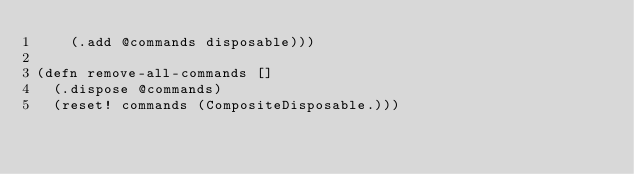<code> <loc_0><loc_0><loc_500><loc_500><_Clojure_>    (.add @commands disposable)))

(defn remove-all-commands []
  (.dispose @commands)
  (reset! commands (CompositeDisposable.)))
</code> 